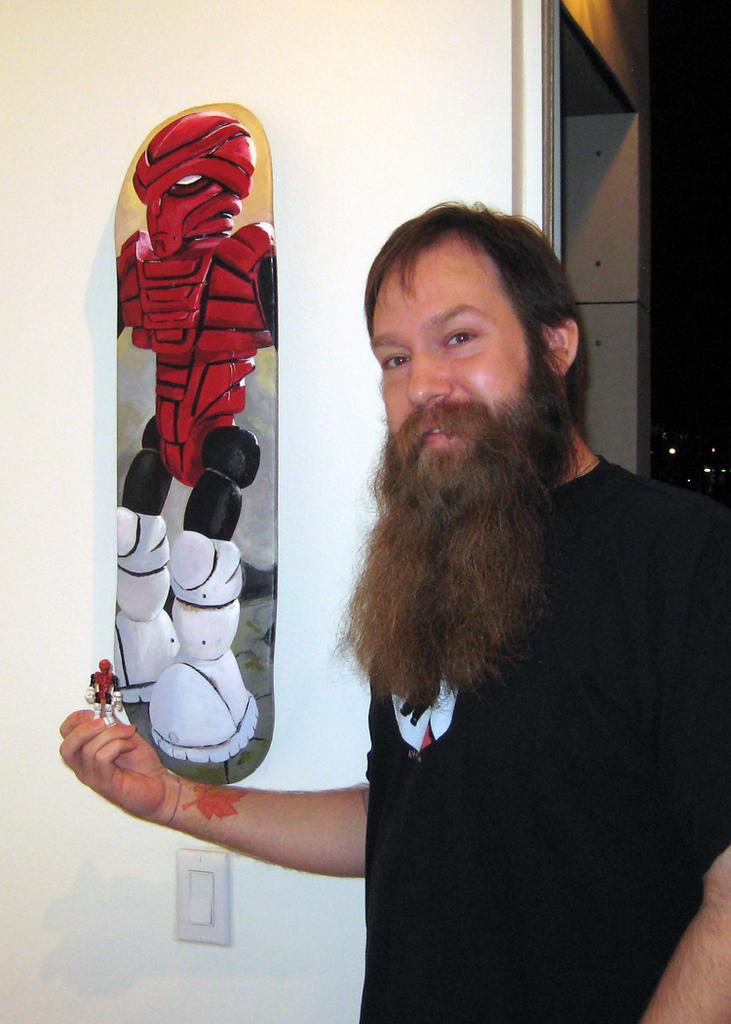Please provide a concise description of this image. In the image we can see there is a person standing and there is a board on the wall. There is a cartoon painting on the board and the man is holding a cartoon toy in his hand. 